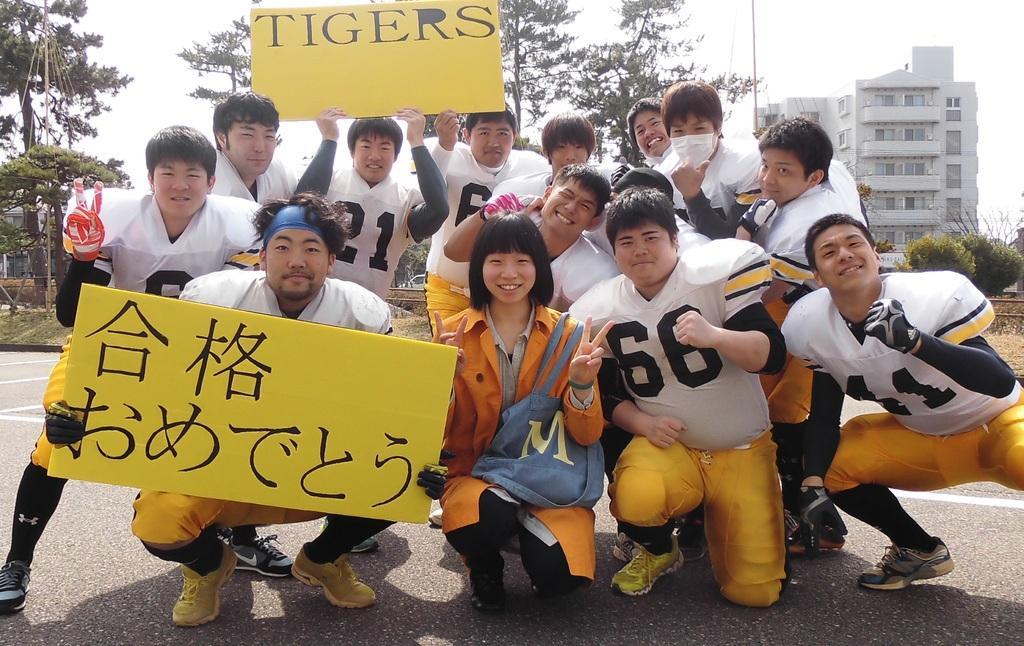Could you give a brief overview of what you see in this image? In the center of the image we can see group of persons on the road holding a boards. In the background there are trees, building, plants, grass and sky. 